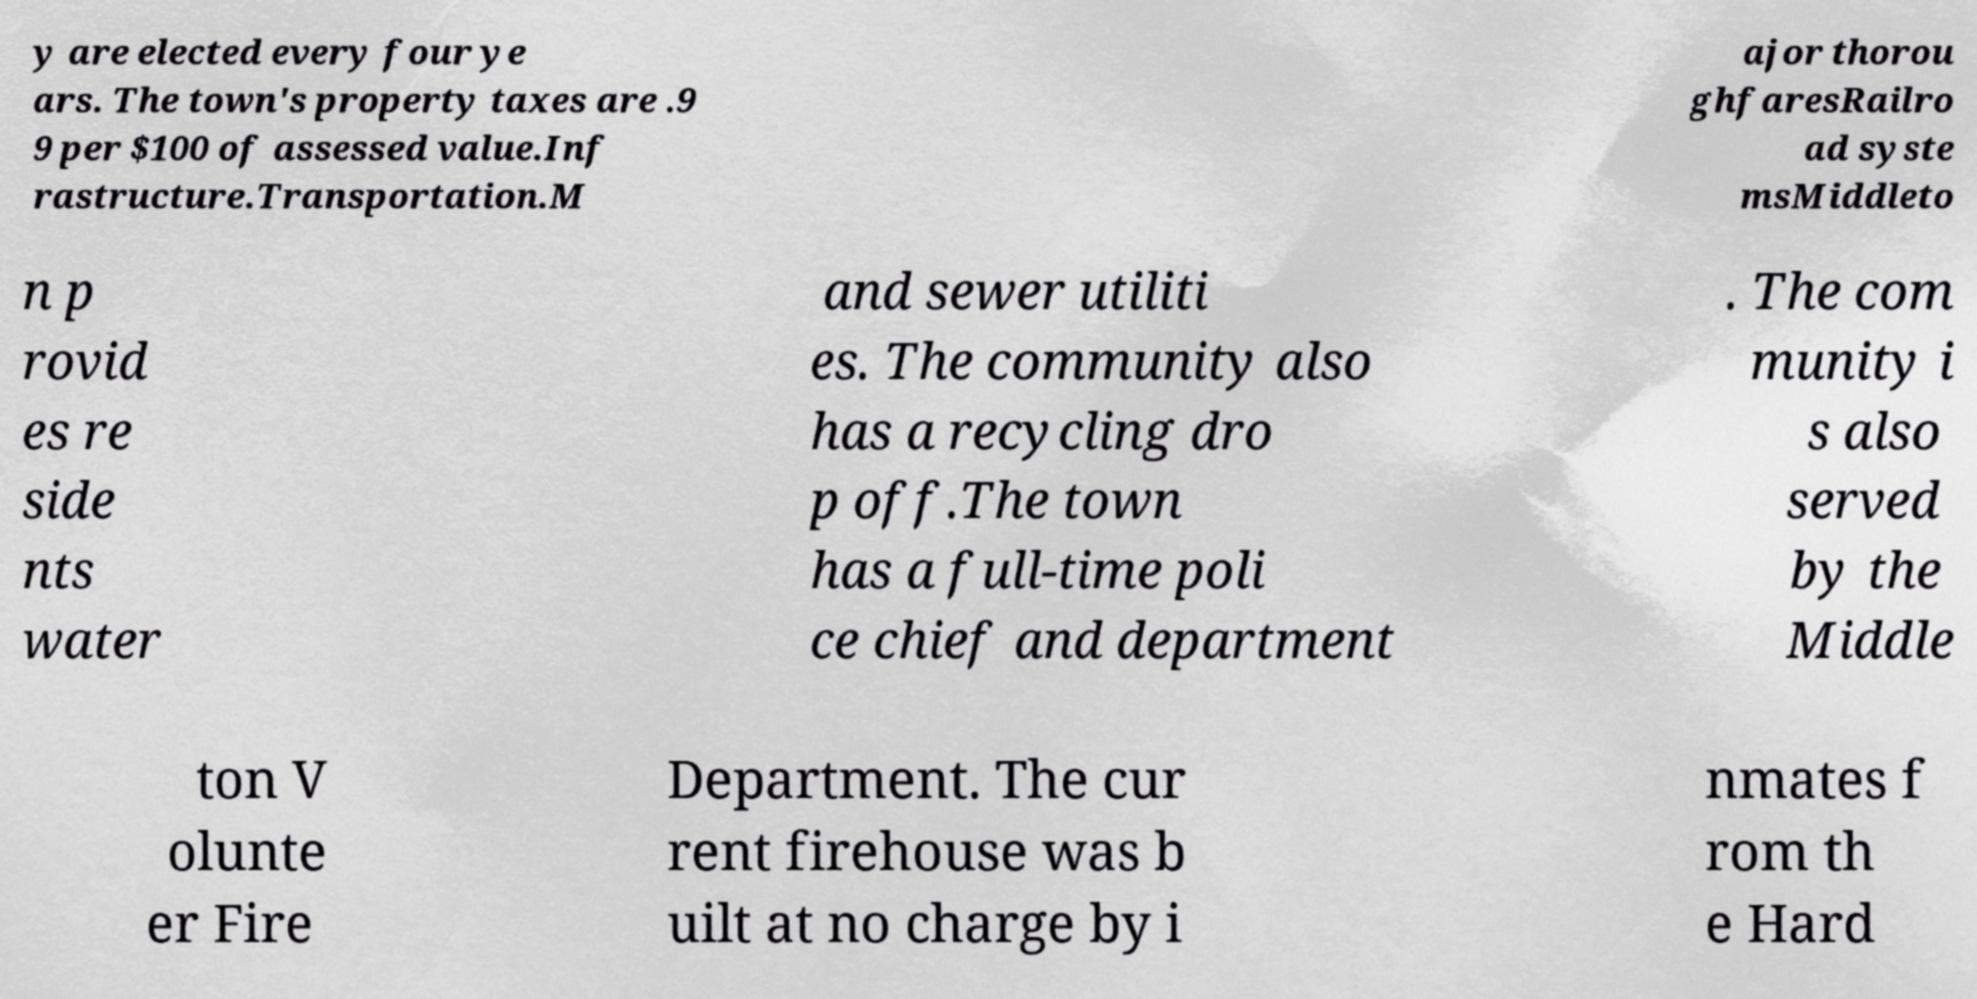For documentation purposes, I need the text within this image transcribed. Could you provide that? y are elected every four ye ars. The town's property taxes are .9 9 per $100 of assessed value.Inf rastructure.Transportation.M ajor thorou ghfaresRailro ad syste msMiddleto n p rovid es re side nts water and sewer utiliti es. The community also has a recycling dro p off.The town has a full-time poli ce chief and department . The com munity i s also served by the Middle ton V olunte er Fire Department. The cur rent firehouse was b uilt at no charge by i nmates f rom th e Hard 